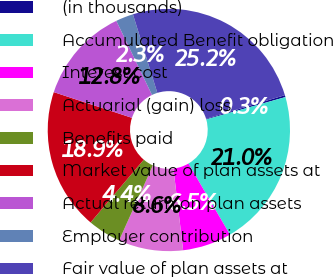Convert chart. <chart><loc_0><loc_0><loc_500><loc_500><pie_chart><fcel>(in thousands)<fcel>Accumulated Benefit obligation<fcel>Interest cost<fcel>Actuarial (gain) loss<fcel>Benefits paid<fcel>Market value of plan assets at<fcel>Actual return on plan assets<fcel>Employer contribution<fcel>Fair value of plan assets at<nl><fcel>0.26%<fcel>20.97%<fcel>6.53%<fcel>8.62%<fcel>4.44%<fcel>18.88%<fcel>12.8%<fcel>2.35%<fcel>25.15%<nl></chart> 